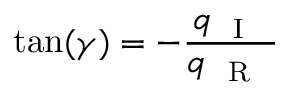<formula> <loc_0><loc_0><loc_500><loc_500>\tan ( \gamma ) = - \frac { q _ { { I } } } { q _ { { R } } }</formula> 